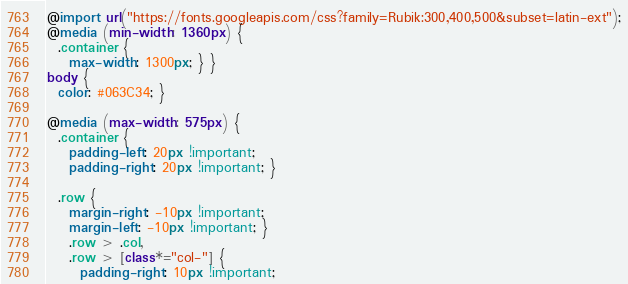<code> <loc_0><loc_0><loc_500><loc_500><_CSS_>@import url("https://fonts.googleapis.com/css?family=Rubik:300,400,500&subset=latin-ext");
@media (min-width: 1360px) {
  .container {
    max-width: 1300px; } }
body {
  color: #063C34; }

@media (max-width: 575px) {
  .container {
    padding-left: 20px !important;
    padding-right: 20px !important; }

  .row {
    margin-right: -10px !important;
    margin-left: -10px !important; }
    .row > .col,
    .row > [class*="col-"] {
      padding-right: 10px !important;</code> 